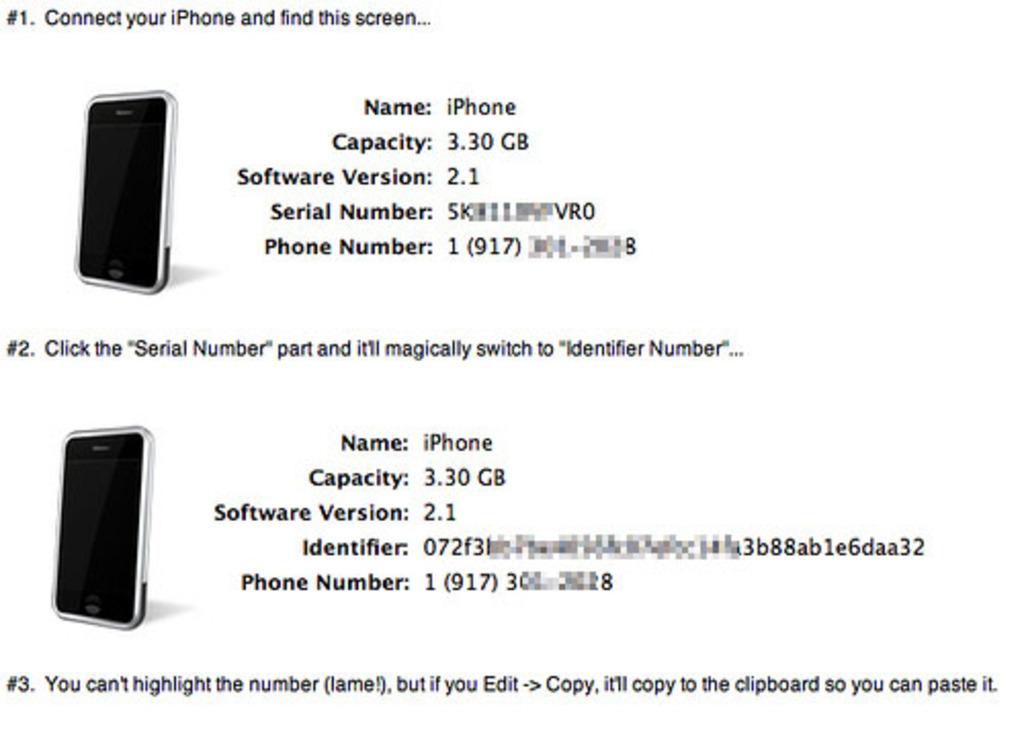What kind of phone are these?
Your answer should be compact. Iphone. What are the phone's capacity?
Provide a short and direct response. 3.30 gb. 